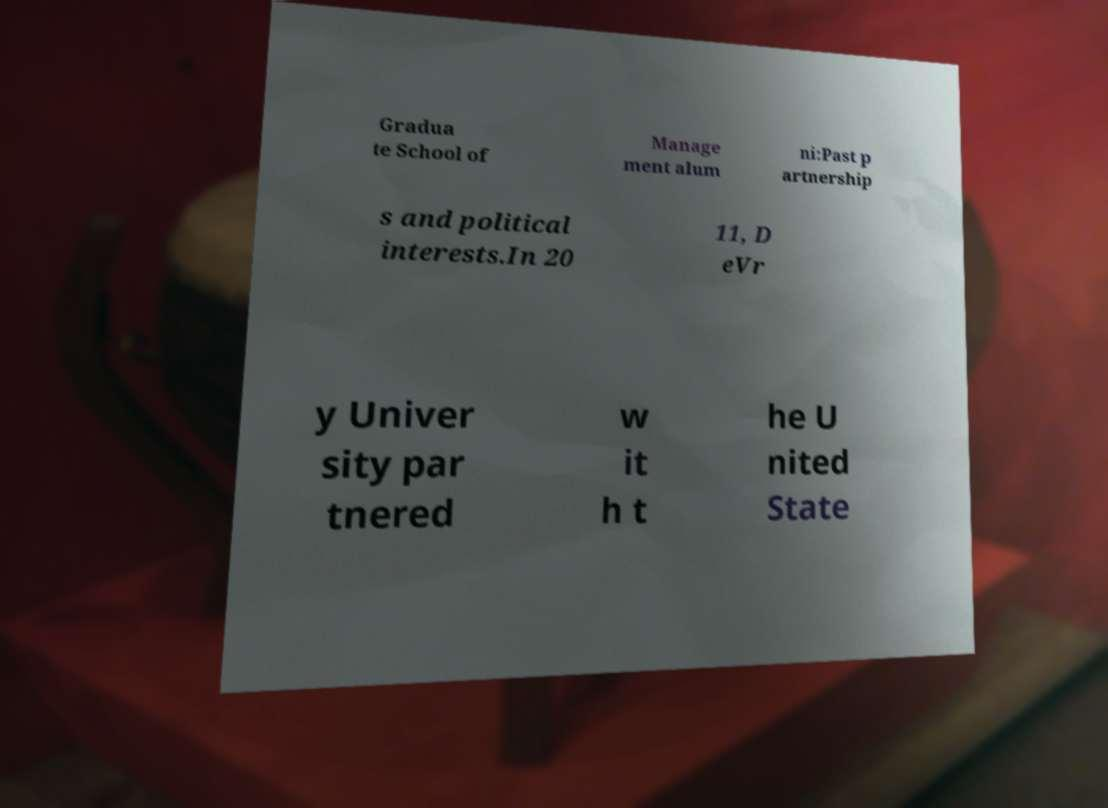Can you read and provide the text displayed in the image?This photo seems to have some interesting text. Can you extract and type it out for me? Gradua te School of Manage ment alum ni:Past p artnership s and political interests.In 20 11, D eVr y Univer sity par tnered w it h t he U nited State 